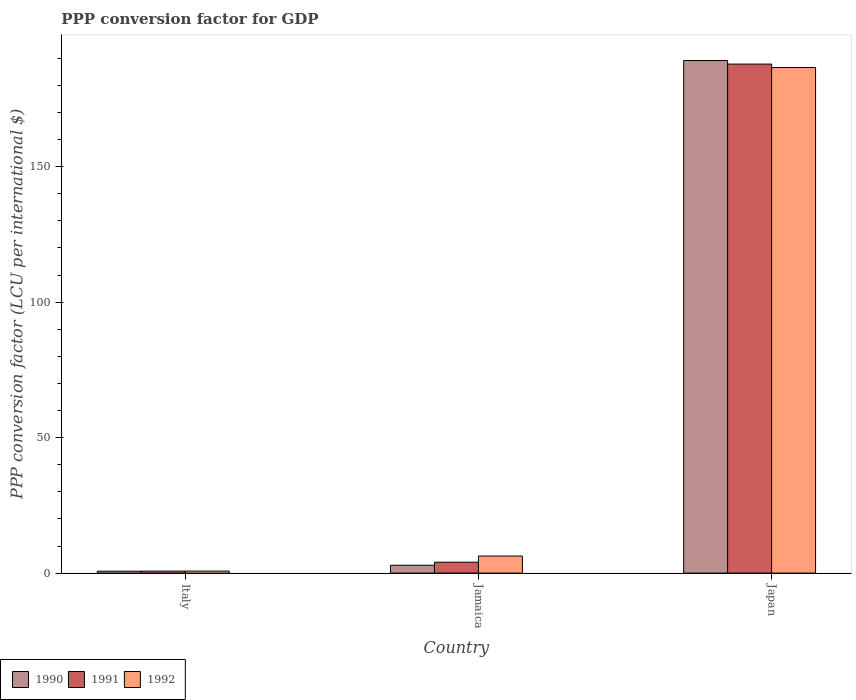How many bars are there on the 2nd tick from the left?
Your answer should be compact. 3. How many bars are there on the 2nd tick from the right?
Make the answer very short. 3. What is the PPP conversion factor for GDP in 1991 in Jamaica?
Make the answer very short. 4.02. Across all countries, what is the maximum PPP conversion factor for GDP in 1992?
Offer a terse response. 186.58. Across all countries, what is the minimum PPP conversion factor for GDP in 1992?
Offer a very short reply. 0.75. In which country was the PPP conversion factor for GDP in 1991 maximum?
Provide a short and direct response. Japan. In which country was the PPP conversion factor for GDP in 1990 minimum?
Make the answer very short. Italy. What is the total PPP conversion factor for GDP in 1991 in the graph?
Ensure brevity in your answer.  192.6. What is the difference between the PPP conversion factor for GDP in 1991 in Italy and that in Jamaica?
Ensure brevity in your answer.  -3.29. What is the difference between the PPP conversion factor for GDP in 1990 in Jamaica and the PPP conversion factor for GDP in 1992 in Japan?
Offer a terse response. -183.69. What is the average PPP conversion factor for GDP in 1992 per country?
Your response must be concise. 64.54. What is the difference between the PPP conversion factor for GDP of/in 1990 and PPP conversion factor for GDP of/in 1991 in Japan?
Provide a succinct answer. 1.32. In how many countries, is the PPP conversion factor for GDP in 1992 greater than 40 LCU?
Make the answer very short. 1. What is the ratio of the PPP conversion factor for GDP in 1992 in Italy to that in Japan?
Make the answer very short. 0. Is the PPP conversion factor for GDP in 1992 in Italy less than that in Jamaica?
Offer a terse response. Yes. What is the difference between the highest and the second highest PPP conversion factor for GDP in 1991?
Offer a very short reply. -187.12. What is the difference between the highest and the lowest PPP conversion factor for GDP in 1991?
Offer a very short reply. 187.12. What does the 2nd bar from the right in Italy represents?
Provide a short and direct response. 1991. Is it the case that in every country, the sum of the PPP conversion factor for GDP in 1992 and PPP conversion factor for GDP in 1991 is greater than the PPP conversion factor for GDP in 1990?
Offer a very short reply. Yes. Are all the bars in the graph horizontal?
Your answer should be compact. No. Are the values on the major ticks of Y-axis written in scientific E-notation?
Provide a short and direct response. No. Does the graph contain any zero values?
Ensure brevity in your answer.  No. Where does the legend appear in the graph?
Your answer should be compact. Bottom left. How many legend labels are there?
Your response must be concise. 3. How are the legend labels stacked?
Offer a terse response. Horizontal. What is the title of the graph?
Your answer should be compact. PPP conversion factor for GDP. Does "1994" appear as one of the legend labels in the graph?
Offer a very short reply. No. What is the label or title of the Y-axis?
Provide a succinct answer. PPP conversion factor (LCU per international $). What is the PPP conversion factor (LCU per international $) in 1990 in Italy?
Your response must be concise. 0.7. What is the PPP conversion factor (LCU per international $) in 1991 in Italy?
Your answer should be compact. 0.73. What is the PPP conversion factor (LCU per international $) of 1992 in Italy?
Keep it short and to the point. 0.75. What is the PPP conversion factor (LCU per international $) in 1990 in Jamaica?
Keep it short and to the point. 2.89. What is the PPP conversion factor (LCU per international $) of 1991 in Jamaica?
Provide a short and direct response. 4.02. What is the PPP conversion factor (LCU per international $) in 1992 in Jamaica?
Provide a succinct answer. 6.3. What is the PPP conversion factor (LCU per international $) of 1990 in Japan?
Your response must be concise. 189.17. What is the PPP conversion factor (LCU per international $) of 1991 in Japan?
Provide a short and direct response. 187.85. What is the PPP conversion factor (LCU per international $) in 1992 in Japan?
Offer a very short reply. 186.58. Across all countries, what is the maximum PPP conversion factor (LCU per international $) in 1990?
Your answer should be compact. 189.17. Across all countries, what is the maximum PPP conversion factor (LCU per international $) in 1991?
Your answer should be very brief. 187.85. Across all countries, what is the maximum PPP conversion factor (LCU per international $) in 1992?
Make the answer very short. 186.58. Across all countries, what is the minimum PPP conversion factor (LCU per international $) of 1990?
Your response must be concise. 0.7. Across all countries, what is the minimum PPP conversion factor (LCU per international $) of 1991?
Make the answer very short. 0.73. Across all countries, what is the minimum PPP conversion factor (LCU per international $) in 1992?
Your answer should be compact. 0.75. What is the total PPP conversion factor (LCU per international $) in 1990 in the graph?
Your answer should be very brief. 192.77. What is the total PPP conversion factor (LCU per international $) of 1991 in the graph?
Provide a succinct answer. 192.6. What is the total PPP conversion factor (LCU per international $) of 1992 in the graph?
Offer a very short reply. 193.62. What is the difference between the PPP conversion factor (LCU per international $) in 1990 in Italy and that in Jamaica?
Offer a very short reply. -2.19. What is the difference between the PPP conversion factor (LCU per international $) of 1991 in Italy and that in Jamaica?
Keep it short and to the point. -3.29. What is the difference between the PPP conversion factor (LCU per international $) of 1992 in Italy and that in Jamaica?
Offer a terse response. -5.55. What is the difference between the PPP conversion factor (LCU per international $) in 1990 in Italy and that in Japan?
Ensure brevity in your answer.  -188.47. What is the difference between the PPP conversion factor (LCU per international $) in 1991 in Italy and that in Japan?
Give a very brief answer. -187.12. What is the difference between the PPP conversion factor (LCU per international $) of 1992 in Italy and that in Japan?
Your response must be concise. -185.83. What is the difference between the PPP conversion factor (LCU per international $) in 1990 in Jamaica and that in Japan?
Offer a very short reply. -186.28. What is the difference between the PPP conversion factor (LCU per international $) of 1991 in Jamaica and that in Japan?
Provide a short and direct response. -183.82. What is the difference between the PPP conversion factor (LCU per international $) in 1992 in Jamaica and that in Japan?
Provide a short and direct response. -180.28. What is the difference between the PPP conversion factor (LCU per international $) in 1990 in Italy and the PPP conversion factor (LCU per international $) in 1991 in Jamaica?
Offer a very short reply. -3.32. What is the difference between the PPP conversion factor (LCU per international $) of 1990 in Italy and the PPP conversion factor (LCU per international $) of 1992 in Jamaica?
Keep it short and to the point. -5.6. What is the difference between the PPP conversion factor (LCU per international $) in 1991 in Italy and the PPP conversion factor (LCU per international $) in 1992 in Jamaica?
Provide a succinct answer. -5.57. What is the difference between the PPP conversion factor (LCU per international $) of 1990 in Italy and the PPP conversion factor (LCU per international $) of 1991 in Japan?
Your response must be concise. -187.15. What is the difference between the PPP conversion factor (LCU per international $) in 1990 in Italy and the PPP conversion factor (LCU per international $) in 1992 in Japan?
Your answer should be very brief. -185.88. What is the difference between the PPP conversion factor (LCU per international $) of 1991 in Italy and the PPP conversion factor (LCU per international $) of 1992 in Japan?
Give a very brief answer. -185.85. What is the difference between the PPP conversion factor (LCU per international $) in 1990 in Jamaica and the PPP conversion factor (LCU per international $) in 1991 in Japan?
Your answer should be very brief. -184.96. What is the difference between the PPP conversion factor (LCU per international $) of 1990 in Jamaica and the PPP conversion factor (LCU per international $) of 1992 in Japan?
Ensure brevity in your answer.  -183.69. What is the difference between the PPP conversion factor (LCU per international $) in 1991 in Jamaica and the PPP conversion factor (LCU per international $) in 1992 in Japan?
Make the answer very short. -182.55. What is the average PPP conversion factor (LCU per international $) of 1990 per country?
Your answer should be compact. 64.26. What is the average PPP conversion factor (LCU per international $) of 1991 per country?
Provide a short and direct response. 64.2. What is the average PPP conversion factor (LCU per international $) in 1992 per country?
Your answer should be very brief. 64.54. What is the difference between the PPP conversion factor (LCU per international $) in 1990 and PPP conversion factor (LCU per international $) in 1991 in Italy?
Offer a terse response. -0.03. What is the difference between the PPP conversion factor (LCU per international $) in 1990 and PPP conversion factor (LCU per international $) in 1992 in Italy?
Your answer should be compact. -0.04. What is the difference between the PPP conversion factor (LCU per international $) in 1991 and PPP conversion factor (LCU per international $) in 1992 in Italy?
Keep it short and to the point. -0.01. What is the difference between the PPP conversion factor (LCU per international $) in 1990 and PPP conversion factor (LCU per international $) in 1991 in Jamaica?
Your answer should be very brief. -1.13. What is the difference between the PPP conversion factor (LCU per international $) in 1990 and PPP conversion factor (LCU per international $) in 1992 in Jamaica?
Make the answer very short. -3.41. What is the difference between the PPP conversion factor (LCU per international $) of 1991 and PPP conversion factor (LCU per international $) of 1992 in Jamaica?
Your response must be concise. -2.27. What is the difference between the PPP conversion factor (LCU per international $) of 1990 and PPP conversion factor (LCU per international $) of 1991 in Japan?
Ensure brevity in your answer.  1.32. What is the difference between the PPP conversion factor (LCU per international $) in 1990 and PPP conversion factor (LCU per international $) in 1992 in Japan?
Provide a succinct answer. 2.59. What is the difference between the PPP conversion factor (LCU per international $) in 1991 and PPP conversion factor (LCU per international $) in 1992 in Japan?
Provide a short and direct response. 1.27. What is the ratio of the PPP conversion factor (LCU per international $) of 1990 in Italy to that in Jamaica?
Give a very brief answer. 0.24. What is the ratio of the PPP conversion factor (LCU per international $) of 1991 in Italy to that in Jamaica?
Your answer should be compact. 0.18. What is the ratio of the PPP conversion factor (LCU per international $) in 1992 in Italy to that in Jamaica?
Your answer should be very brief. 0.12. What is the ratio of the PPP conversion factor (LCU per international $) in 1990 in Italy to that in Japan?
Give a very brief answer. 0. What is the ratio of the PPP conversion factor (LCU per international $) in 1991 in Italy to that in Japan?
Your answer should be very brief. 0. What is the ratio of the PPP conversion factor (LCU per international $) of 1992 in Italy to that in Japan?
Make the answer very short. 0. What is the ratio of the PPP conversion factor (LCU per international $) in 1990 in Jamaica to that in Japan?
Your answer should be compact. 0.02. What is the ratio of the PPP conversion factor (LCU per international $) of 1991 in Jamaica to that in Japan?
Your answer should be very brief. 0.02. What is the ratio of the PPP conversion factor (LCU per international $) in 1992 in Jamaica to that in Japan?
Your answer should be compact. 0.03. What is the difference between the highest and the second highest PPP conversion factor (LCU per international $) in 1990?
Provide a short and direct response. 186.28. What is the difference between the highest and the second highest PPP conversion factor (LCU per international $) in 1991?
Your response must be concise. 183.82. What is the difference between the highest and the second highest PPP conversion factor (LCU per international $) in 1992?
Make the answer very short. 180.28. What is the difference between the highest and the lowest PPP conversion factor (LCU per international $) in 1990?
Your answer should be compact. 188.47. What is the difference between the highest and the lowest PPP conversion factor (LCU per international $) in 1991?
Your response must be concise. 187.12. What is the difference between the highest and the lowest PPP conversion factor (LCU per international $) in 1992?
Provide a short and direct response. 185.83. 